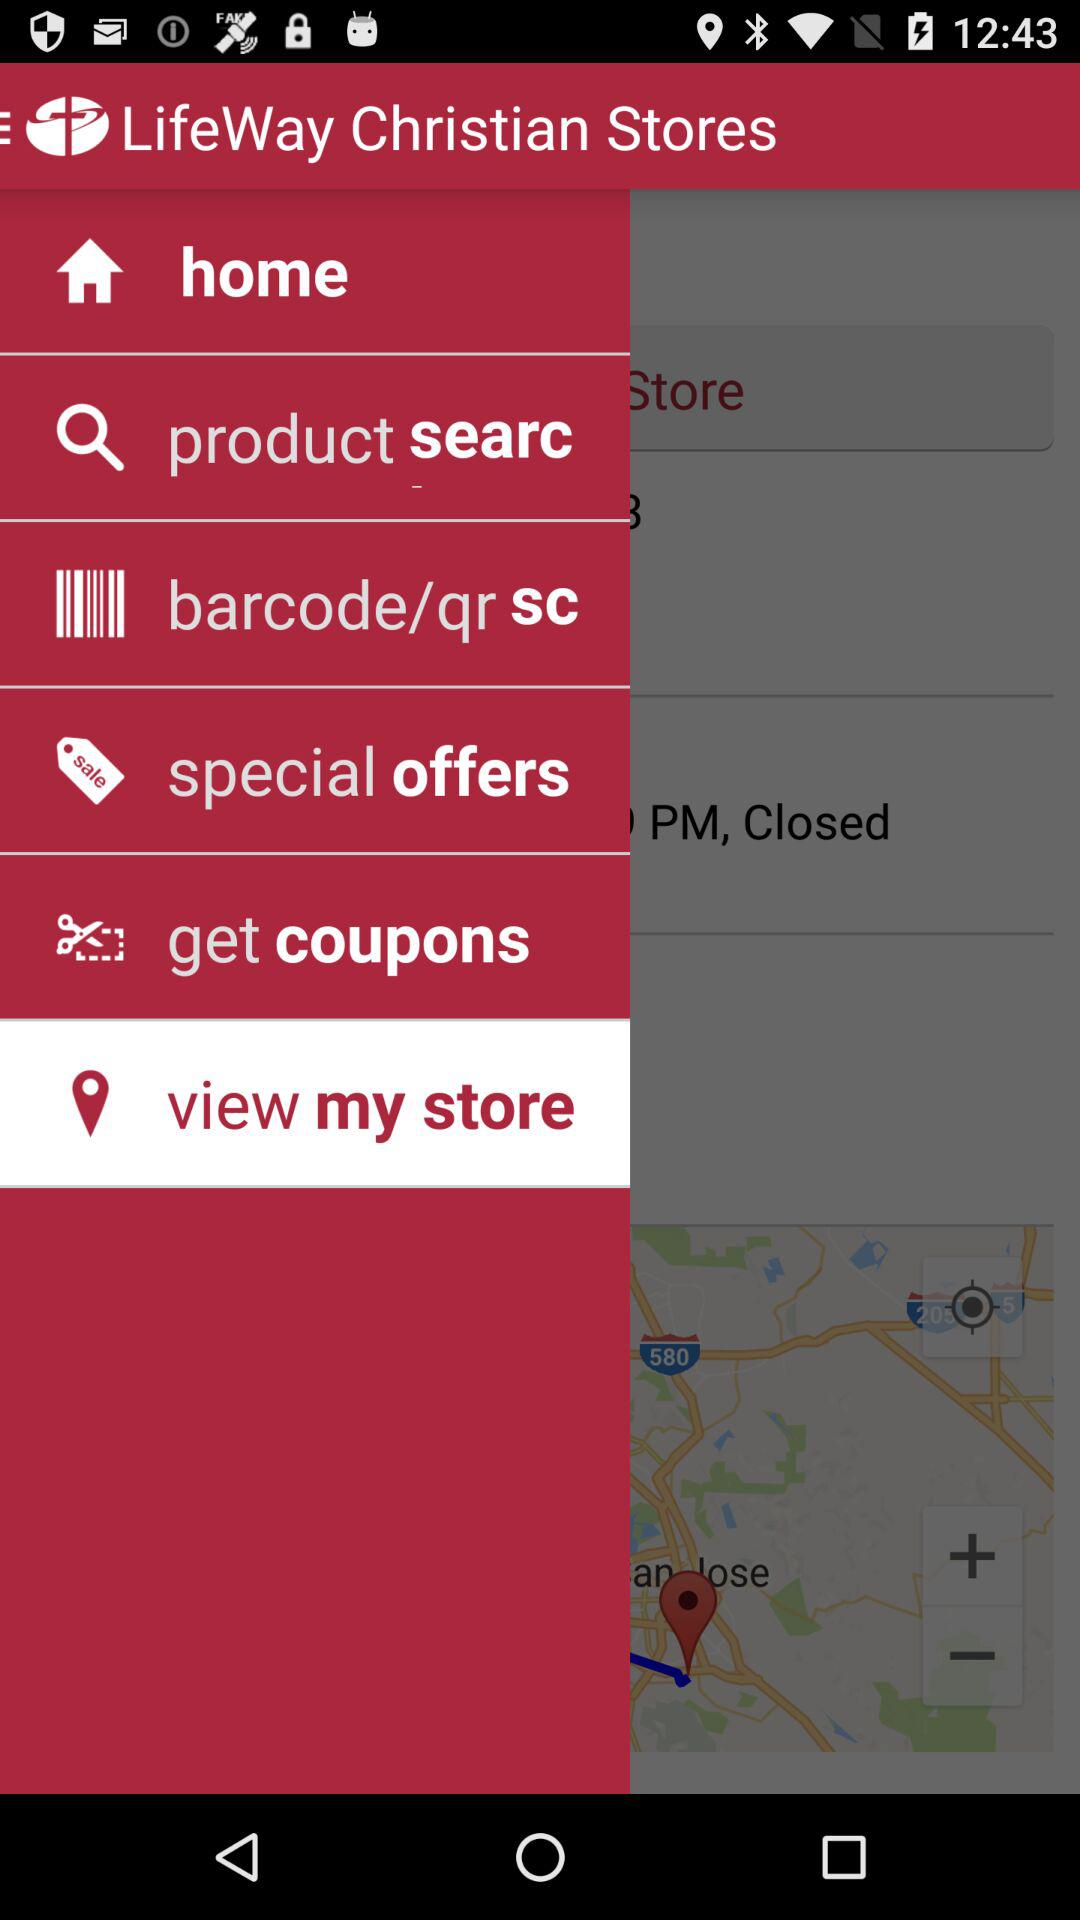How many special offers are there available?
When the provided information is insufficient, respond with <no answer>. <no answer> 